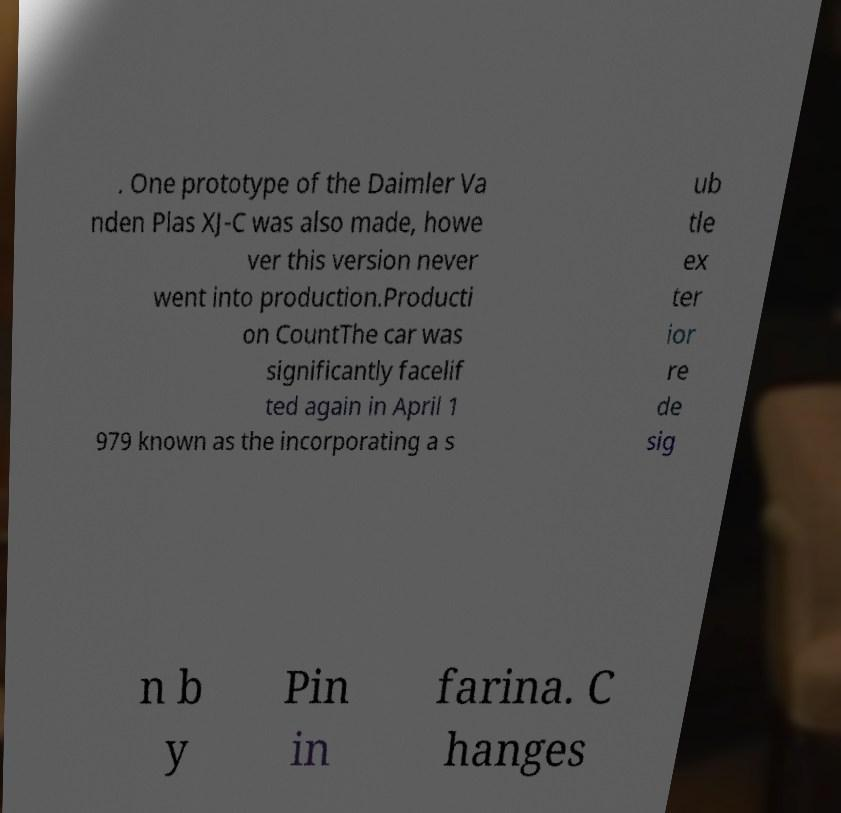I need the written content from this picture converted into text. Can you do that? . One prototype of the Daimler Va nden Plas XJ-C was also made, howe ver this version never went into production.Producti on CountThe car was significantly facelif ted again in April 1 979 known as the incorporating a s ub tle ex ter ior re de sig n b y Pin in farina. C hanges 